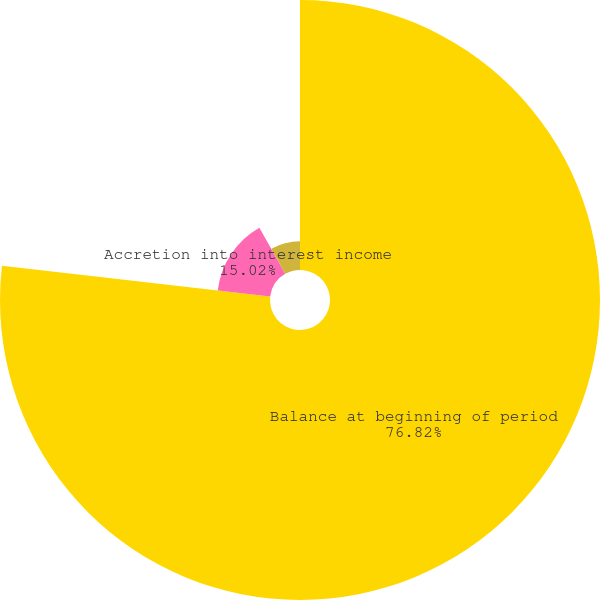<chart> <loc_0><loc_0><loc_500><loc_500><pie_chart><fcel>Balance at beginning of period<fcel>Accretion into interest income<fcel>Other changes in expected cash<nl><fcel>76.82%<fcel>15.02%<fcel>8.16%<nl></chart> 